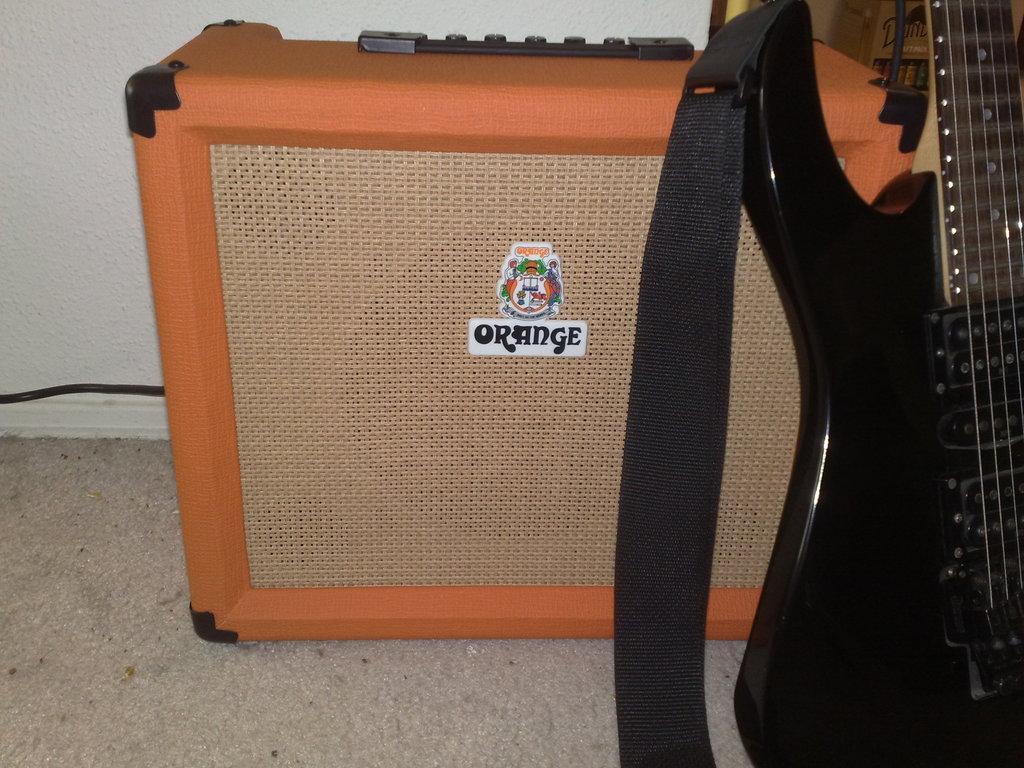Can you describe this image briefly? In the picture there is a wall and floor. The floor consists of one box and it is in orange colour and guitar beside to it with a belt. 